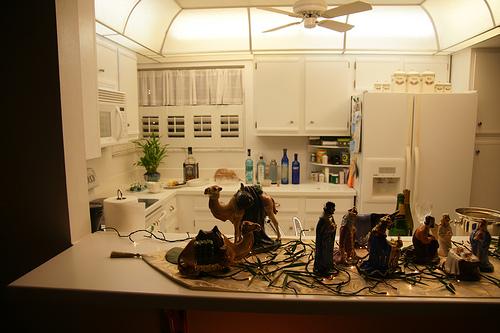Is the light bright in this room?
Concise answer only. Yes. What color is the refrigerator?
Keep it brief. White. What room is this?
Keep it brief. Kitchen. Which color is dominant?
Quick response, please. White. 